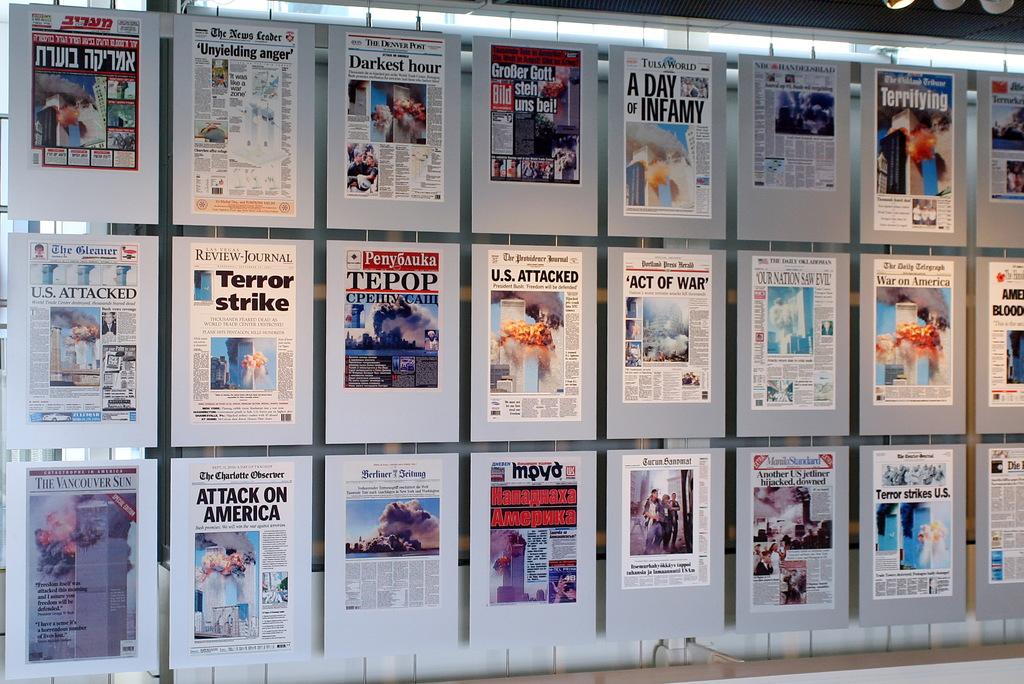What kind of strike?
Your answer should be compact. Terror. What kind of day does the top newspaper say?
Offer a very short reply. A day of infamy. 